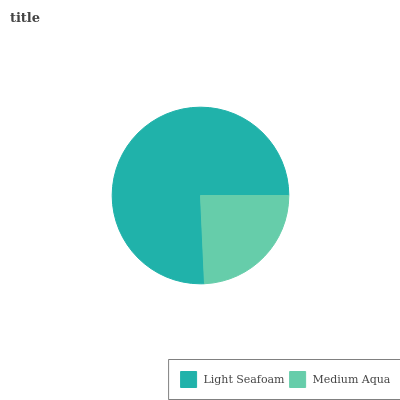Is Medium Aqua the minimum?
Answer yes or no. Yes. Is Light Seafoam the maximum?
Answer yes or no. Yes. Is Medium Aqua the maximum?
Answer yes or no. No. Is Light Seafoam greater than Medium Aqua?
Answer yes or no. Yes. Is Medium Aqua less than Light Seafoam?
Answer yes or no. Yes. Is Medium Aqua greater than Light Seafoam?
Answer yes or no. No. Is Light Seafoam less than Medium Aqua?
Answer yes or no. No. Is Light Seafoam the high median?
Answer yes or no. Yes. Is Medium Aqua the low median?
Answer yes or no. Yes. Is Medium Aqua the high median?
Answer yes or no. No. Is Light Seafoam the low median?
Answer yes or no. No. 